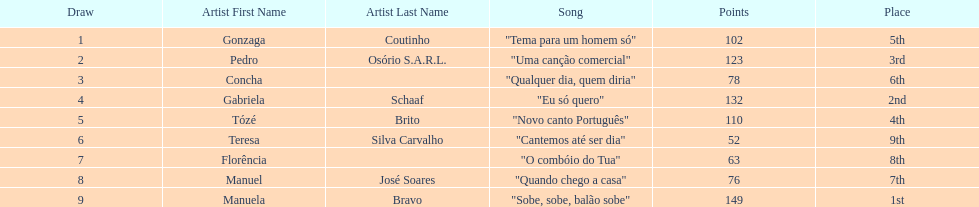Who was the last draw? Manuela Bravo. 